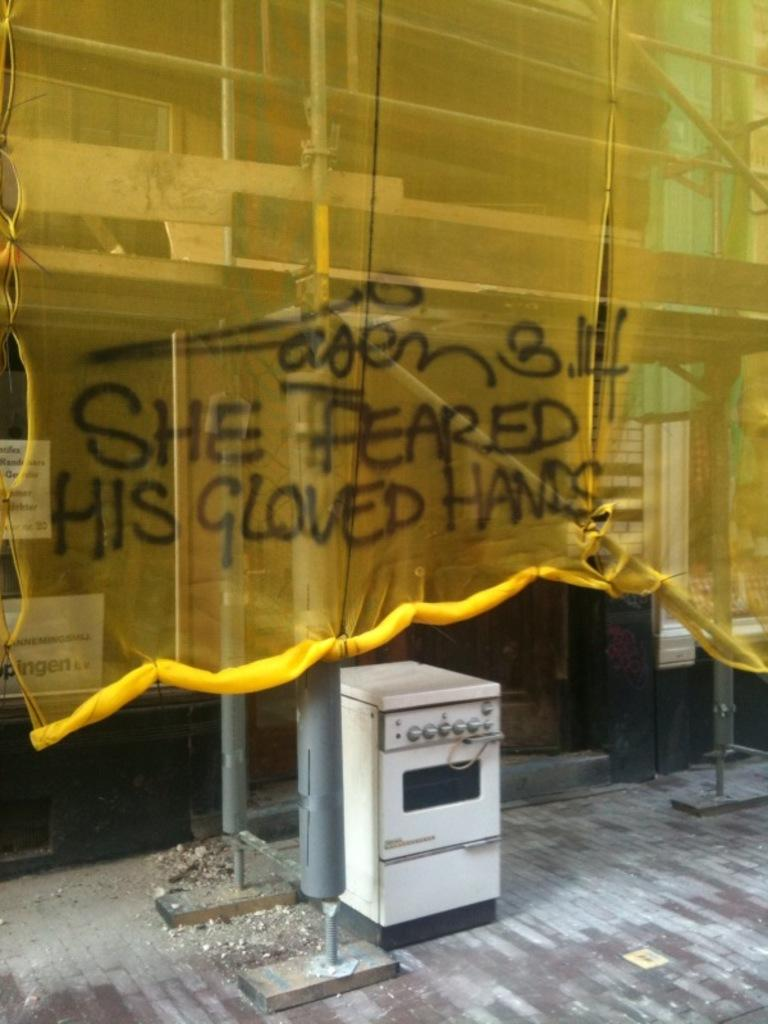Provide a one-sentence caption for the provided image. A construction site that has a yellow see through tarp over it that has graffiti that says She feared his gloved hand on it. 